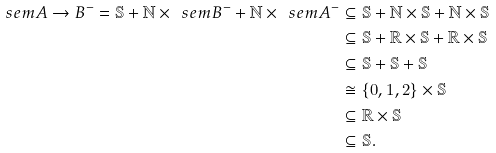Convert formula to latex. <formula><loc_0><loc_0><loc_500><loc_500>\ s e m { A \to B } ^ { - } = \mathbb { S } + \mathbb { N } \times \ s e m { B } ^ { - } + \mathbb { N } \times \ s e m { A } ^ { - } & \subseteq \mathbb { S } + \mathbb { N } \times \mathbb { S } + \mathbb { N } \times \mathbb { S } \\ & \subseteq \mathbb { S } + \mathbb { R } \times \mathbb { S } + \mathbb { R } \times \mathbb { S } \\ & \subseteq \mathbb { S } + \mathbb { S } + \mathbb { S } \\ & \cong \{ 0 , 1 , 2 \} \times \mathbb { S } \\ & \subseteq \mathbb { R } \times \mathbb { S } \\ & \subseteq \mathbb { S } .</formula> 